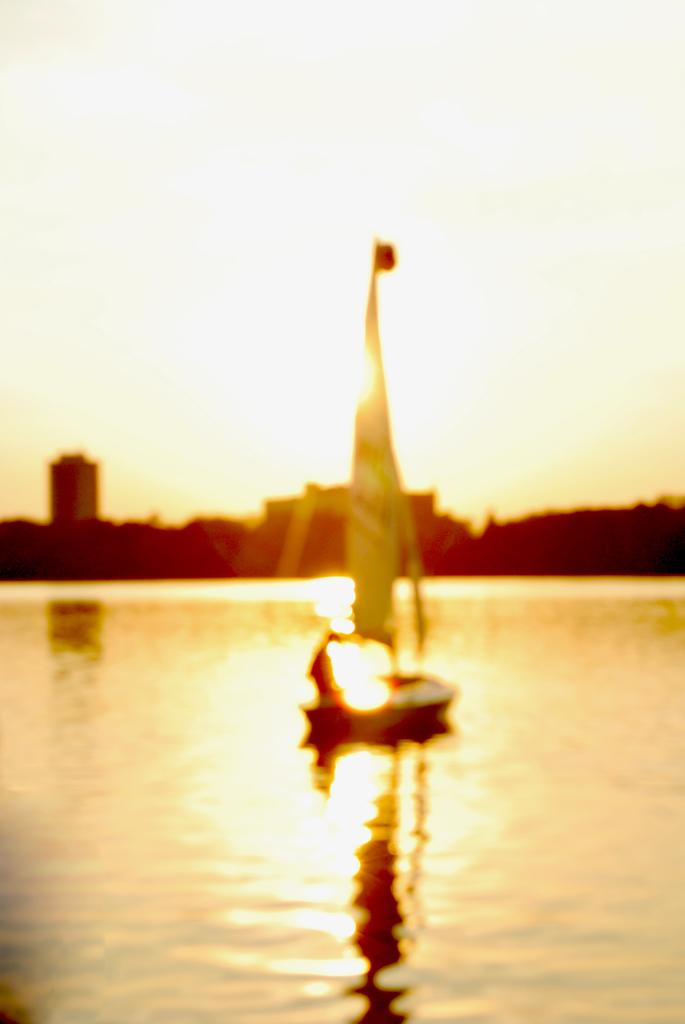What is the main subject of the image? The main subject of the image is water. What is located on the water in the image? There is a boat on the water in the image. What can be seen in the background of the image? There are houses and trees in the background of the image. What is visible above the water and the boat in the image? The sky is visible in the image. What type of lace can be seen on the boat in the image? There is no lace visible on the boat in the image. How does the faucet contribute to the journey of the boat in the image? There is no faucet present in the image, so it cannot contribute to the journey of the boat. 